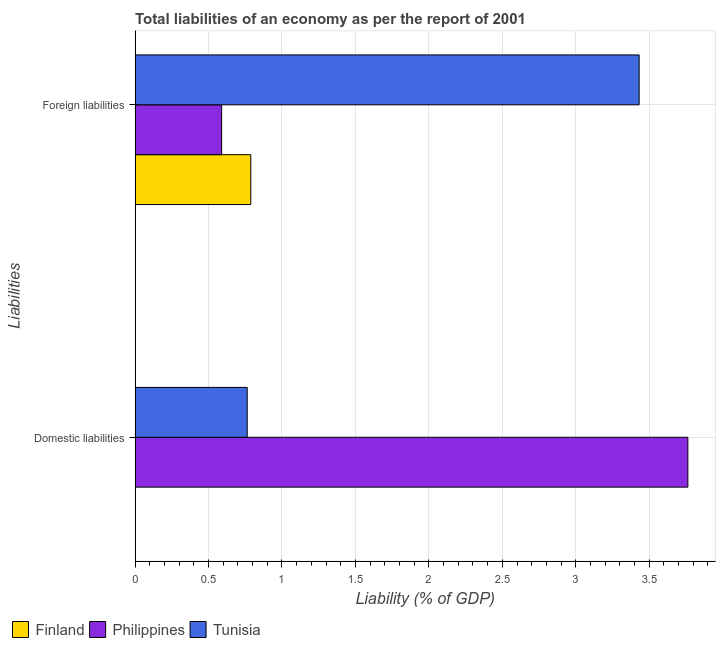How many different coloured bars are there?
Ensure brevity in your answer.  3. What is the label of the 1st group of bars from the top?
Offer a very short reply. Foreign liabilities. What is the incurrence of domestic liabilities in Finland?
Keep it short and to the point. 0. Across all countries, what is the maximum incurrence of domestic liabilities?
Your answer should be very brief. 3.76. Across all countries, what is the minimum incurrence of foreign liabilities?
Provide a short and direct response. 0.59. In which country was the incurrence of domestic liabilities maximum?
Provide a succinct answer. Philippines. What is the total incurrence of foreign liabilities in the graph?
Your response must be concise. 4.81. What is the difference between the incurrence of foreign liabilities in Tunisia and that in Philippines?
Your answer should be compact. 2.84. What is the difference between the incurrence of domestic liabilities in Tunisia and the incurrence of foreign liabilities in Philippines?
Your answer should be very brief. 0.17. What is the average incurrence of foreign liabilities per country?
Ensure brevity in your answer.  1.6. What is the difference between the incurrence of foreign liabilities and incurrence of domestic liabilities in Philippines?
Make the answer very short. -3.17. In how many countries, is the incurrence of foreign liabilities greater than 1.2 %?
Your response must be concise. 1. What is the ratio of the incurrence of foreign liabilities in Finland to that in Philippines?
Your answer should be very brief. 1.34. Is the incurrence of foreign liabilities in Tunisia less than that in Finland?
Ensure brevity in your answer.  No. In how many countries, is the incurrence of domestic liabilities greater than the average incurrence of domestic liabilities taken over all countries?
Your answer should be compact. 1. How many bars are there?
Provide a succinct answer. 5. Are all the bars in the graph horizontal?
Provide a succinct answer. Yes. Are the values on the major ticks of X-axis written in scientific E-notation?
Offer a very short reply. No. Does the graph contain any zero values?
Offer a terse response. Yes. Does the graph contain grids?
Give a very brief answer. Yes. Where does the legend appear in the graph?
Offer a terse response. Bottom left. How many legend labels are there?
Your answer should be compact. 3. What is the title of the graph?
Make the answer very short. Total liabilities of an economy as per the report of 2001. Does "Ghana" appear as one of the legend labels in the graph?
Offer a terse response. No. What is the label or title of the X-axis?
Ensure brevity in your answer.  Liability (% of GDP). What is the label or title of the Y-axis?
Provide a succinct answer. Liabilities. What is the Liability (% of GDP) of Finland in Domestic liabilities?
Your answer should be very brief. 0. What is the Liability (% of GDP) in Philippines in Domestic liabilities?
Your answer should be compact. 3.76. What is the Liability (% of GDP) of Tunisia in Domestic liabilities?
Make the answer very short. 0.76. What is the Liability (% of GDP) in Finland in Foreign liabilities?
Make the answer very short. 0.79. What is the Liability (% of GDP) of Philippines in Foreign liabilities?
Your answer should be very brief. 0.59. What is the Liability (% of GDP) of Tunisia in Foreign liabilities?
Keep it short and to the point. 3.43. Across all Liabilities, what is the maximum Liability (% of GDP) in Finland?
Make the answer very short. 0.79. Across all Liabilities, what is the maximum Liability (% of GDP) of Philippines?
Your answer should be compact. 3.76. Across all Liabilities, what is the maximum Liability (% of GDP) in Tunisia?
Ensure brevity in your answer.  3.43. Across all Liabilities, what is the minimum Liability (% of GDP) of Finland?
Keep it short and to the point. 0. Across all Liabilities, what is the minimum Liability (% of GDP) of Philippines?
Keep it short and to the point. 0.59. Across all Liabilities, what is the minimum Liability (% of GDP) of Tunisia?
Your answer should be very brief. 0.76. What is the total Liability (% of GDP) of Finland in the graph?
Provide a succinct answer. 0.79. What is the total Liability (% of GDP) of Philippines in the graph?
Your response must be concise. 4.35. What is the total Liability (% of GDP) of Tunisia in the graph?
Your answer should be compact. 4.19. What is the difference between the Liability (% of GDP) of Philippines in Domestic liabilities and that in Foreign liabilities?
Your response must be concise. 3.17. What is the difference between the Liability (% of GDP) in Tunisia in Domestic liabilities and that in Foreign liabilities?
Your answer should be compact. -2.67. What is the difference between the Liability (% of GDP) of Philippines in Domestic liabilities and the Liability (% of GDP) of Tunisia in Foreign liabilities?
Your answer should be compact. 0.33. What is the average Liability (% of GDP) in Finland per Liabilities?
Provide a short and direct response. 0.39. What is the average Liability (% of GDP) in Philippines per Liabilities?
Provide a succinct answer. 2.18. What is the average Liability (% of GDP) of Tunisia per Liabilities?
Offer a very short reply. 2.1. What is the difference between the Liability (% of GDP) in Philippines and Liability (% of GDP) in Tunisia in Domestic liabilities?
Provide a short and direct response. 3. What is the difference between the Liability (% of GDP) in Finland and Liability (% of GDP) in Philippines in Foreign liabilities?
Offer a very short reply. 0.2. What is the difference between the Liability (% of GDP) in Finland and Liability (% of GDP) in Tunisia in Foreign liabilities?
Provide a succinct answer. -2.64. What is the difference between the Liability (% of GDP) of Philippines and Liability (% of GDP) of Tunisia in Foreign liabilities?
Keep it short and to the point. -2.84. What is the ratio of the Liability (% of GDP) of Philippines in Domestic liabilities to that in Foreign liabilities?
Give a very brief answer. 6.39. What is the ratio of the Liability (% of GDP) in Tunisia in Domestic liabilities to that in Foreign liabilities?
Your answer should be compact. 0.22. What is the difference between the highest and the second highest Liability (% of GDP) in Philippines?
Ensure brevity in your answer.  3.17. What is the difference between the highest and the second highest Liability (% of GDP) of Tunisia?
Provide a short and direct response. 2.67. What is the difference between the highest and the lowest Liability (% of GDP) in Finland?
Ensure brevity in your answer.  0.79. What is the difference between the highest and the lowest Liability (% of GDP) in Philippines?
Your response must be concise. 3.17. What is the difference between the highest and the lowest Liability (% of GDP) in Tunisia?
Your response must be concise. 2.67. 